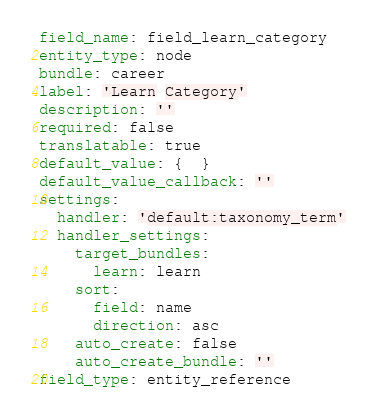Convert code to text. <code><loc_0><loc_0><loc_500><loc_500><_YAML_>field_name: field_learn_category
entity_type: node
bundle: career
label: 'Learn Category'
description: ''
required: false
translatable: true
default_value: {  }
default_value_callback: ''
settings:
  handler: 'default:taxonomy_term'
  handler_settings:
    target_bundles:
      learn: learn
    sort:
      field: name
      direction: asc
    auto_create: false
    auto_create_bundle: ''
field_type: entity_reference
</code> 